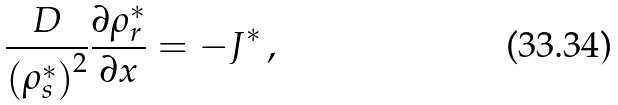Convert formula to latex. <formula><loc_0><loc_0><loc_500><loc_500>\frac { D } { \left ( \rho _ { s } ^ { \ast } \right ) ^ { 2 } } \frac { \partial \rho _ { r } ^ { \ast } } { \partial x } = - J ^ { \ast } \, ,</formula> 